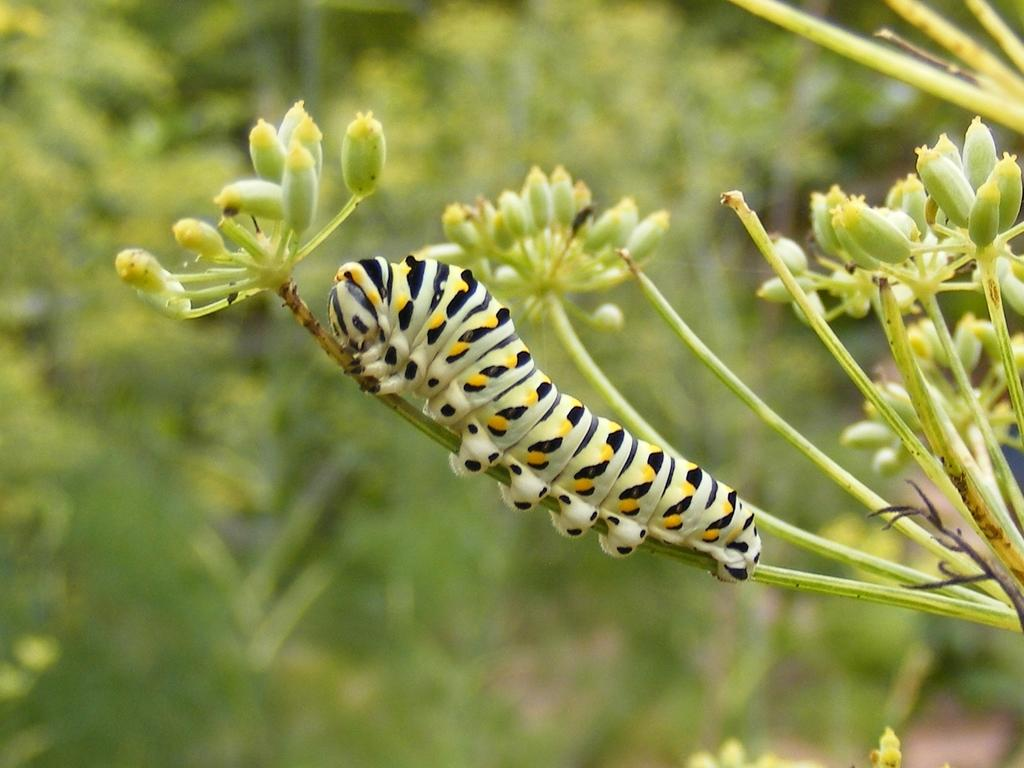What is the main subject of the image? The main subject of the image is a part of a plant with flower buds. Are there any other living organisms present in the image? Yes, a caterpillar is present on the stem of the plant. What can be seen in the background of the image? There are many plants visible behind the main plant, but they are not clearly visible. What topic is being discussed by the plants in the image? There is no discussion taking place among the plants in the image, as plants do not have the ability to engage in discussions. 